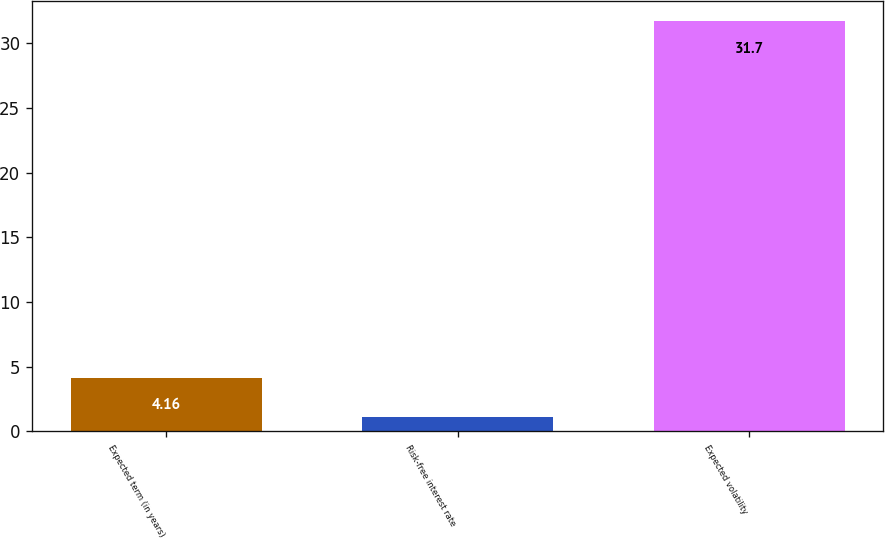Convert chart to OTSL. <chart><loc_0><loc_0><loc_500><loc_500><bar_chart><fcel>Expected term (in years)<fcel>Risk-free interest rate<fcel>Expected volatility<nl><fcel>4.16<fcel>1.1<fcel>31.7<nl></chart> 